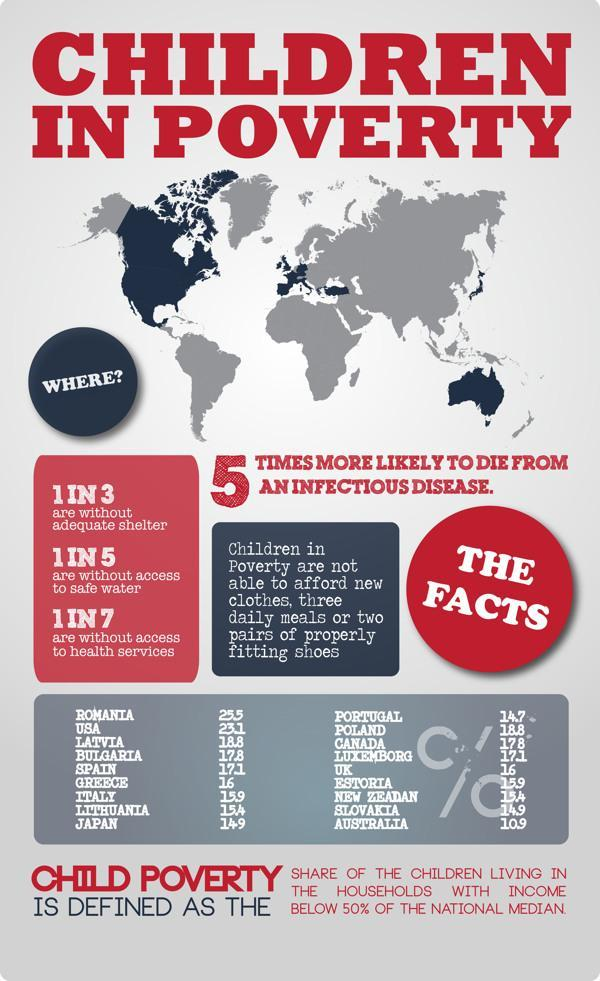Which country has the tenth largest percentage of Children in poverty?
Answer the question with a short phrase. Portugal Which country has the Fifth largest percentage of Children in poverty? Spain Which country has the most number of children in poverty? Romania Which country has the ninth largest percentage of Children in poverty? Japan Which country has the sixth largest percentage of Children in poverty? Greece Which country has the second largest percentage of Children in poverty? USA 